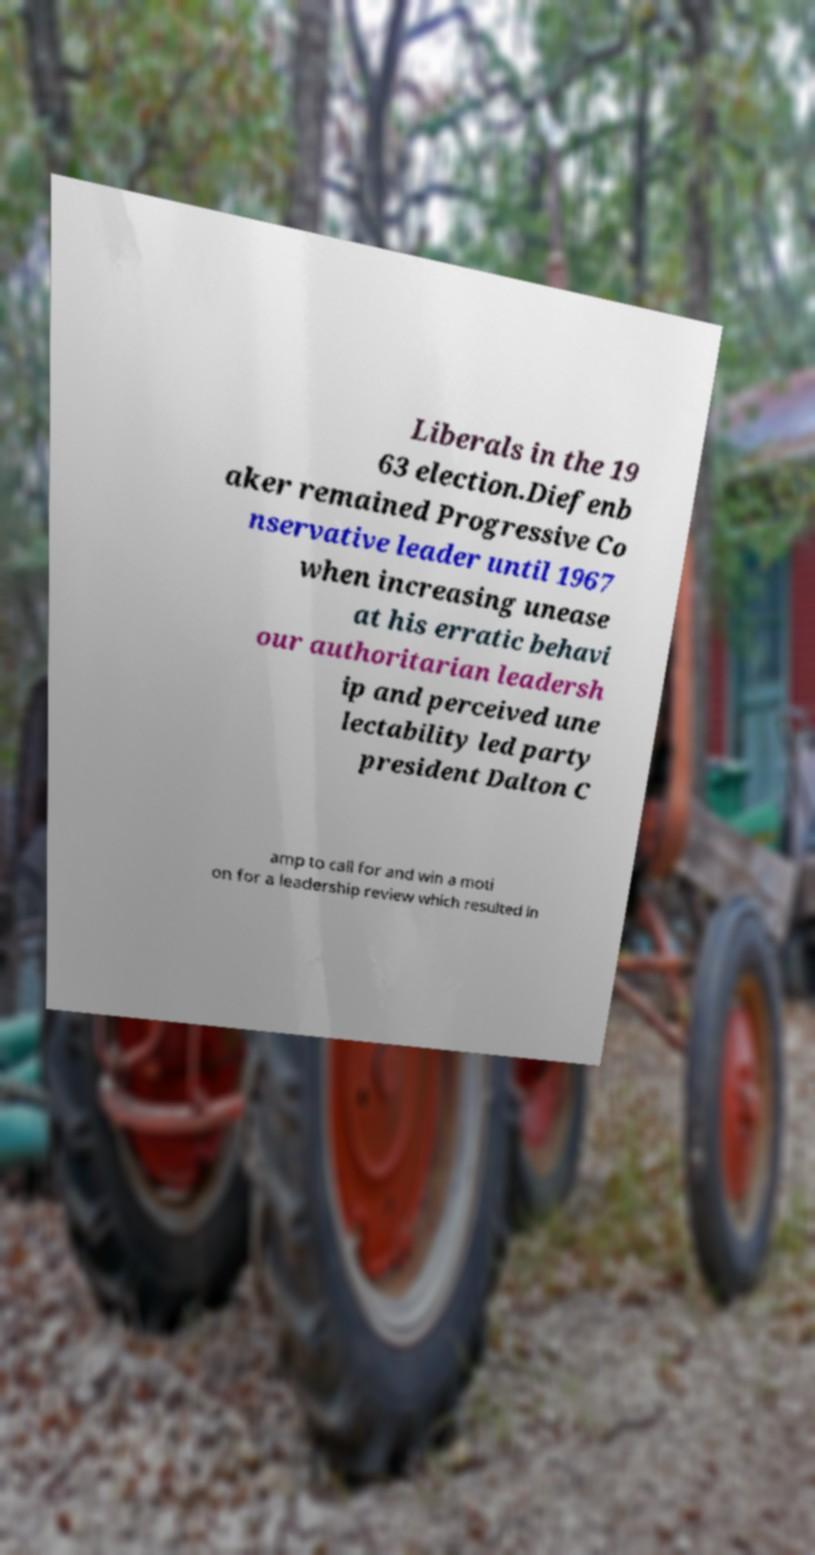Could you assist in decoding the text presented in this image and type it out clearly? Liberals in the 19 63 election.Diefenb aker remained Progressive Co nservative leader until 1967 when increasing unease at his erratic behavi our authoritarian leadersh ip and perceived une lectability led party president Dalton C amp to call for and win a moti on for a leadership review which resulted in 